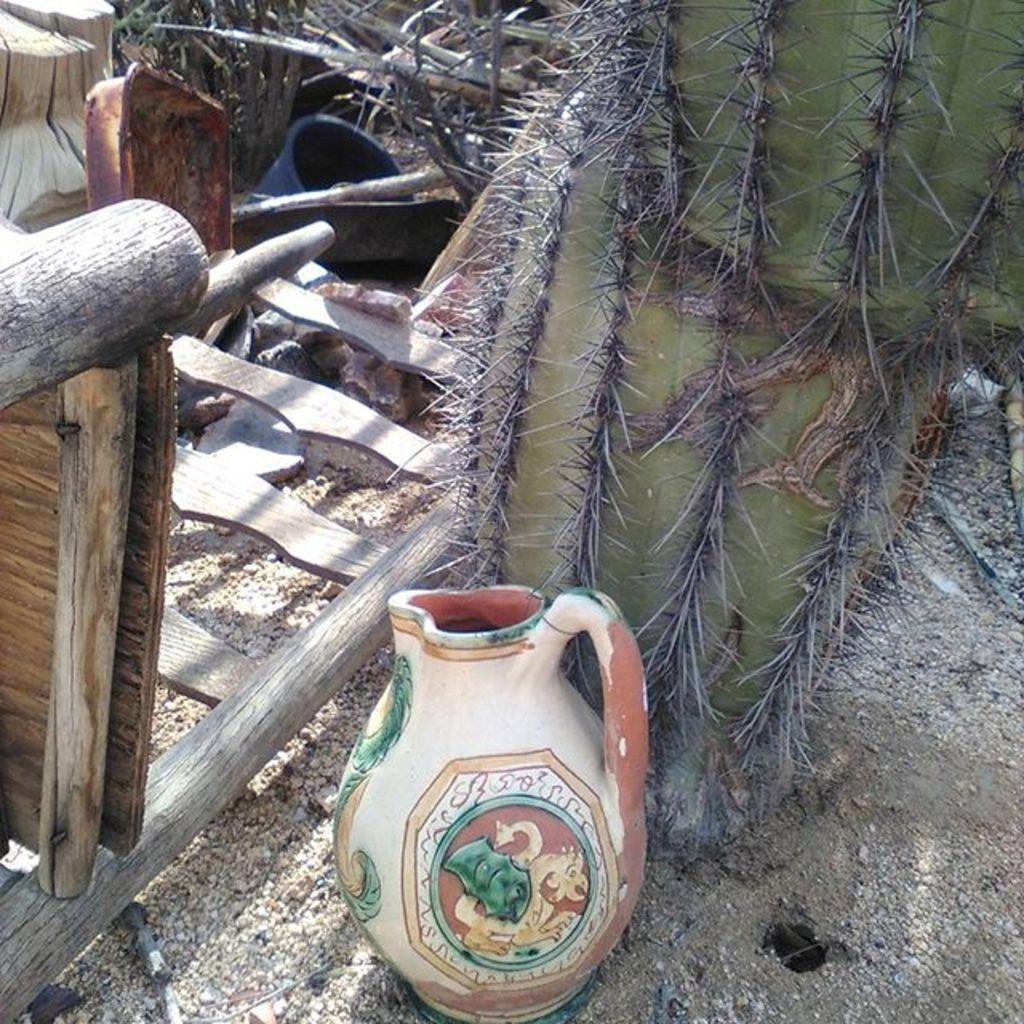What is located in the foreground of the image? There is a pot and a desert plant in the foreground of the image. What can be seen on the left side of the image? There is a wooden object and a bucket on the left side of the image. It also appears there is a plant on the left side of the image. Can you describe the object at the top of the image? There is a tree trunk at the top of the image. What type of worm can be seen crawling on the tree trunk in the image? There are no worms present in the image; only a tree trunk is visible at the top of the image. Is there a man in the image causing destruction to the desert plant? There is no man or destruction present in the image. 